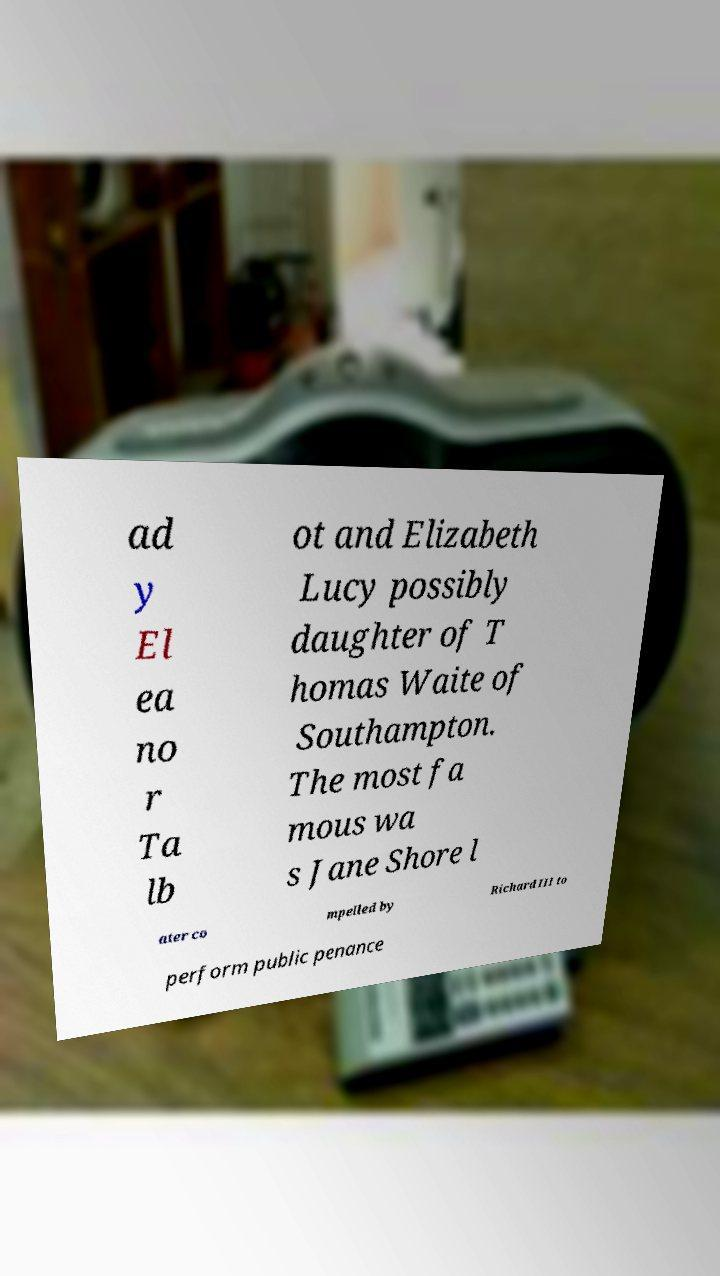What messages or text are displayed in this image? I need them in a readable, typed format. ad y El ea no r Ta lb ot and Elizabeth Lucy possibly daughter of T homas Waite of Southampton. The most fa mous wa s Jane Shore l ater co mpelled by Richard III to perform public penance 